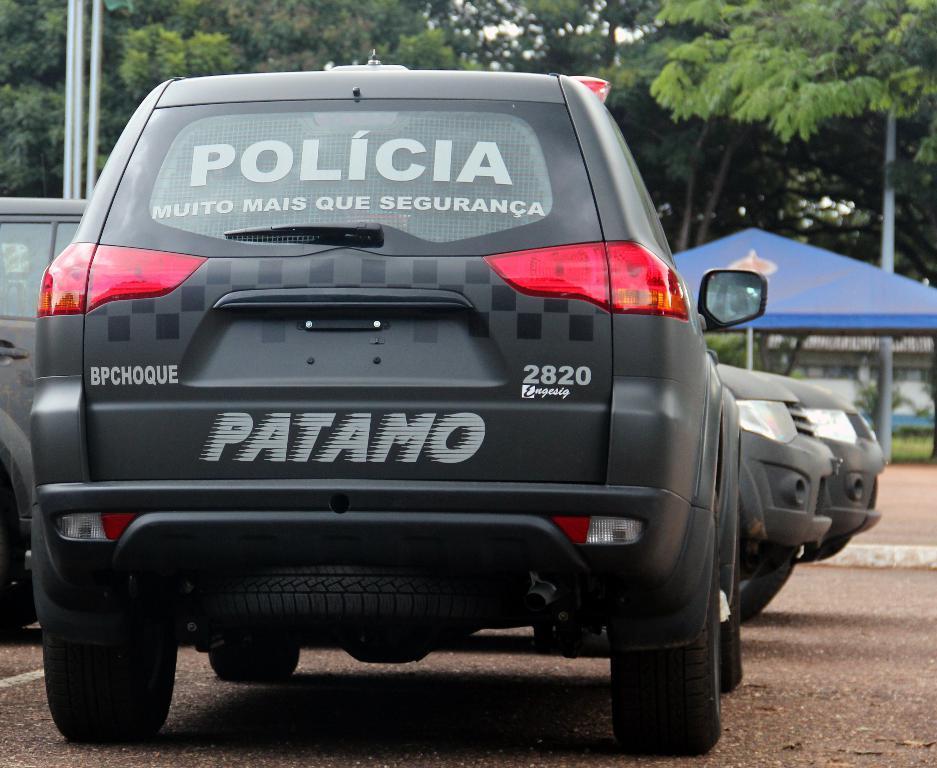Can you describe this image briefly? In this image I can see three cars. I can see some text on backside of the car. In the background I can see few trees. On the left side I can see a tent. 